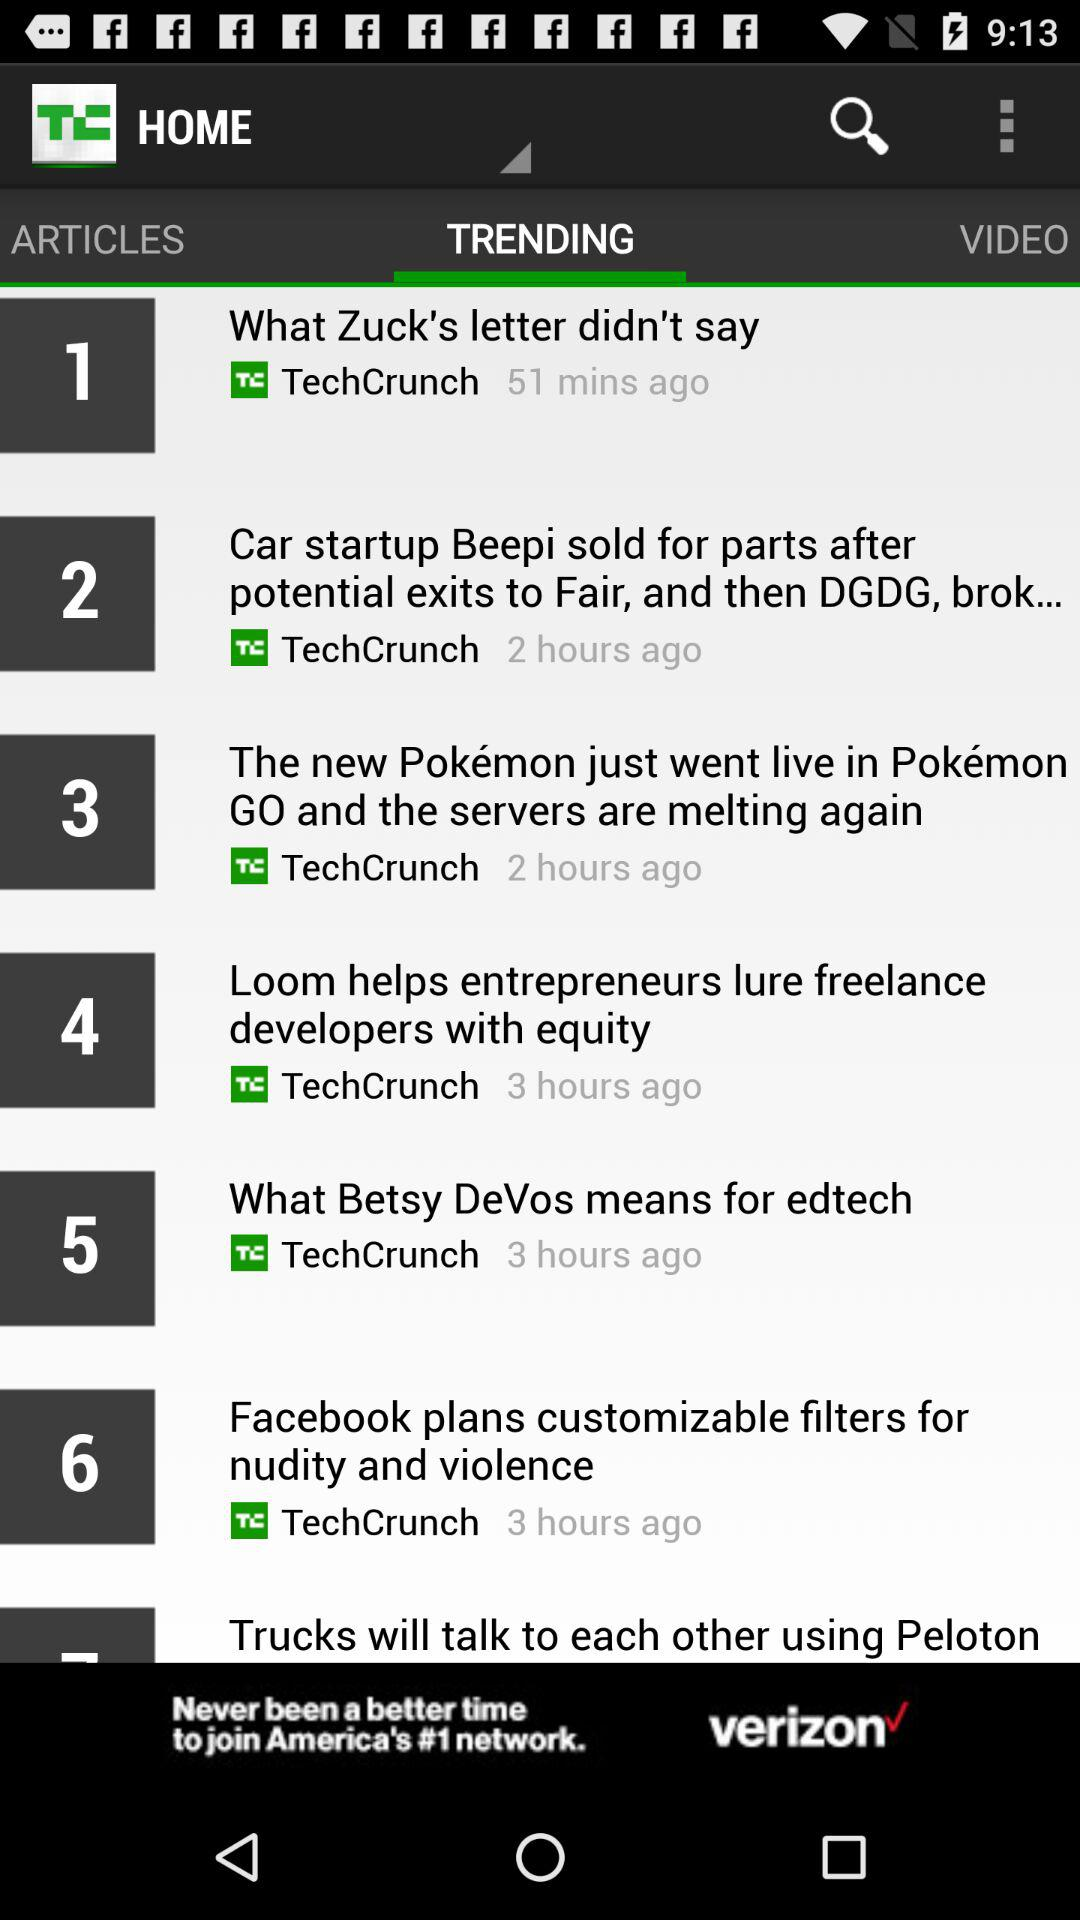What tab is selected? The selected tab is "TRENDING". 